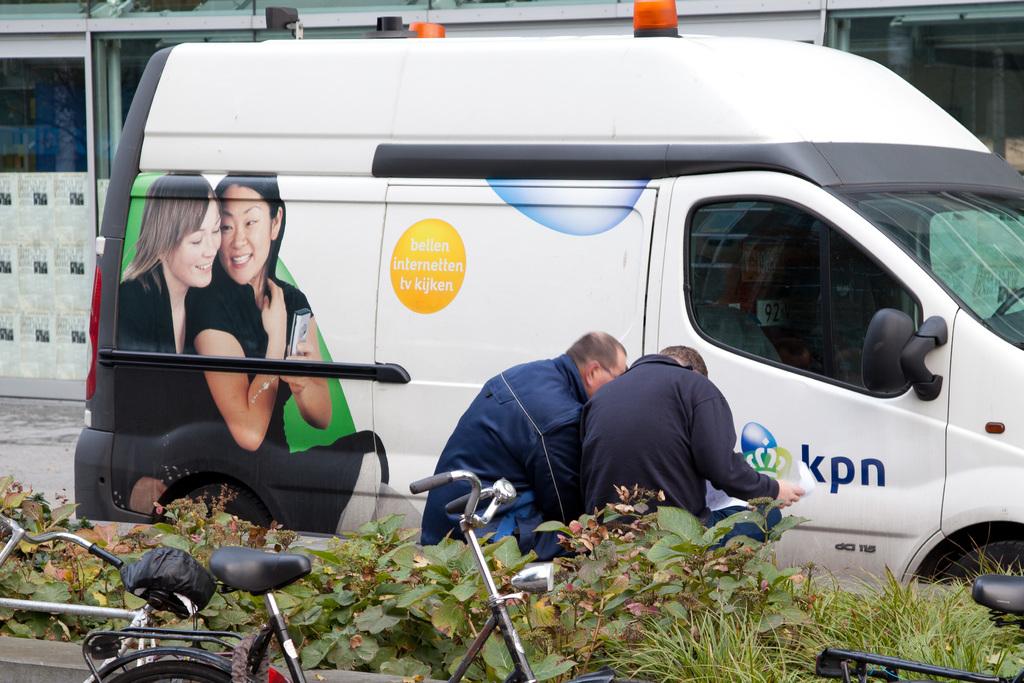What is the name of the company on the van?
Your response must be concise. Kpn. What is the number of the van?
Your answer should be very brief. 115. 